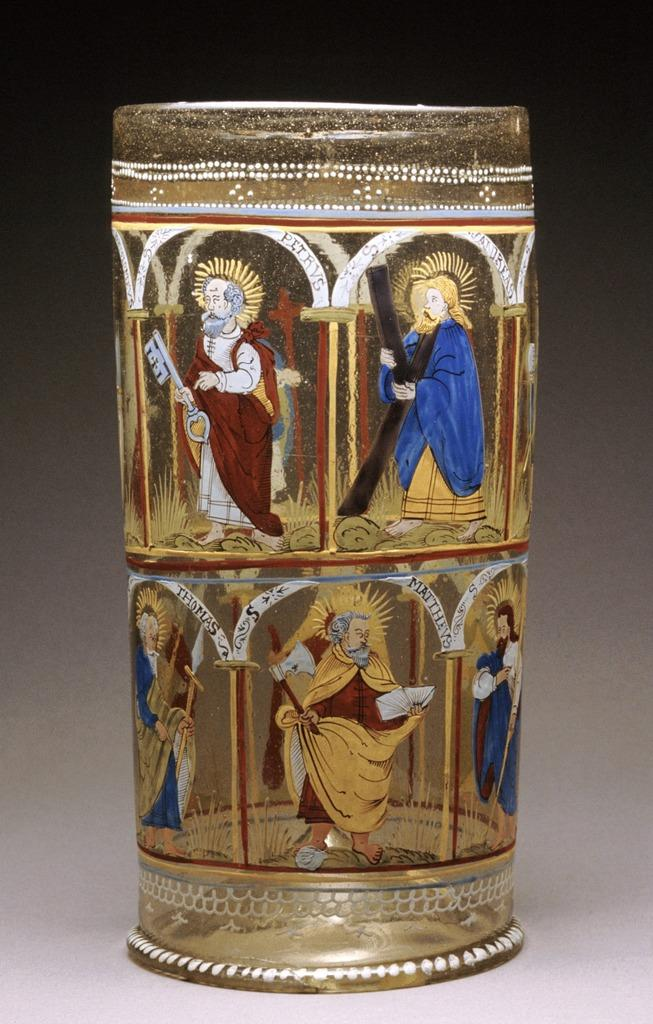What object is present in the image that can hold liquid? There is a glass in the image. What is depicted on the glass? The glass has paintings of persons on it. Where is the glass located in the image? The glass is placed on the floor. What color are the cherries on the glass in the image? There are no cherries present on the glass in the image. What is your opinion on the artistic style of the paintings on the glass? The provided facts do not include any information about the artistic style of the paintings, so it is not possible to provide an opinion on it. 